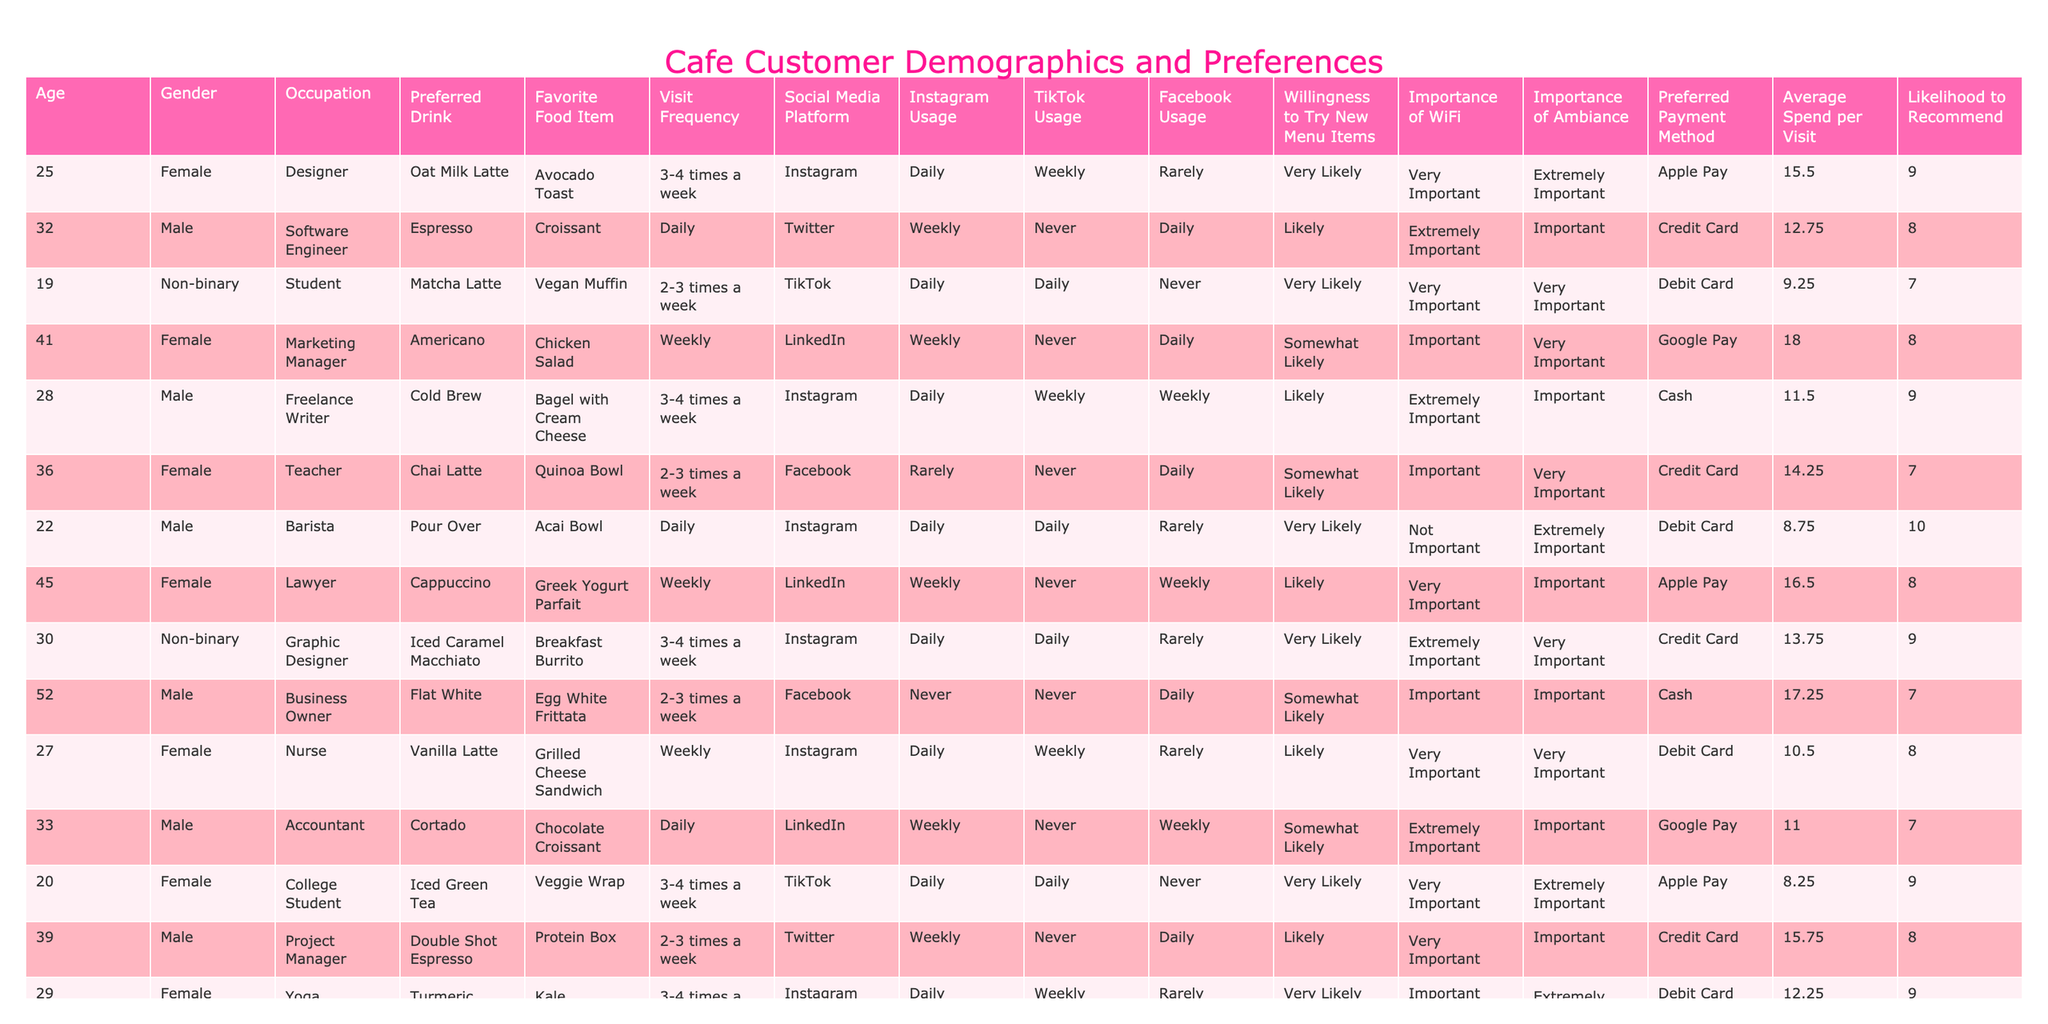What is the most preferred drink among customers? By reviewing the "Preferred Drink" column, it's clear that "Oat Milk Latte" appears most frequently listed, appearing 3 times in the table.
Answer: Oat Milk Latte Which social media platform do most customers use? The "Social Media Platform" column shows "Instagram" is listed most often, appearing 8 times among the customer entries.
Answer: Instagram What percent of customers visit the cafe daily? To determine this, I count the entries with "Daily" in the "Visit Frequency" column, which totals 8 out of 26; therefore, the percentage is (8/26) * 100 = 30.77%, which rounds to 31%.
Answer: 31% Is there a notable difference in average spend between male and female customers? Calculate the average spend for each gender: Females (15.50 + 18.00 + 14.25 + 10.50 + 12.25 + 14.00 + 13.25 + 10.75) =  93.50/8 = 11.69; Males (12.75 + 17.25 + 16.75 + 11.00 + 15.75 + 19.50) = 93.00/6 = 15.50; the difference is 15.50 - 11.69 = 3.81.
Answer: 3.81 How many customers indicated that "Importance of WiFi" is "Extremely Important"? By scanning the "Importance of WiFi" column, I find that 8 customers marked it as "Extremely Important".
Answer: 8 What is the average likelihood to recommend the cafe across all customers? Sum the values in the "Likelihood to Recommend" column (9 + 8 + 7 + 8 + 9 + 7 + 10 + 8 + 9 + 8 + 7 + 9 + 8 + 10 + 8 + 7) = 141, and dividing by the number of customers gives 141/16 = 8.81, so rounding results in a value of 9.
Answer: 9 Do customers who prefer Instagram tend to spend more on average than those preferring Facebook? Calculate the average for Instagram (15.50 + 11.50 + 8.75 + 12.25 + 14.00 + 10.75 = 73.75/8) = 9.22 and for Facebook (14.25 + 19.50 + 10.50 = 44.25/4) = 11.06; the comparison shows that those preferring Facebook have a higher average of 11.06 than Instagram's 9.22.
Answer: No How does the willingness to try new menu items correlate with visit frequency? Looking at visit frequency against "Willingness to Try New Menu Items," those visiting daily often show "Very Likely" to try, while those visiting weekly or less express varying degrees of willingness; hence, a pattern indicates more frequent visits lead to higher willingness.
Answer: Correlates positively Are there any non-binary customers that regularly visit the cafe? Check the "Visit Frequency" for non-binary individuals; one customer visits daily, confirming that there's at least one non-binary patron who frequents the cafe.
Answer: Yes What is the most expensive average spend and which customer represents it? The highest average spend identified is with the customer in the "Occupation" of "Professor" who spends an average of 19.50 per visit.
Answer: Professor, 19.50 